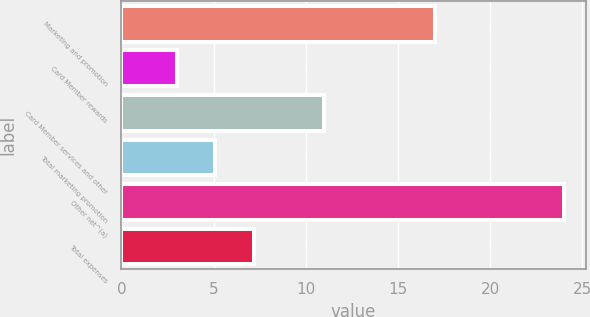<chart> <loc_0><loc_0><loc_500><loc_500><bar_chart><fcel>Marketing and promotion<fcel>Card Member rewards<fcel>Card Member services and other<fcel>Total marketing promotion<fcel>Other net^(a)<fcel>Total expenses<nl><fcel>17<fcel>3<fcel>11<fcel>5.1<fcel>24<fcel>7.2<nl></chart> 